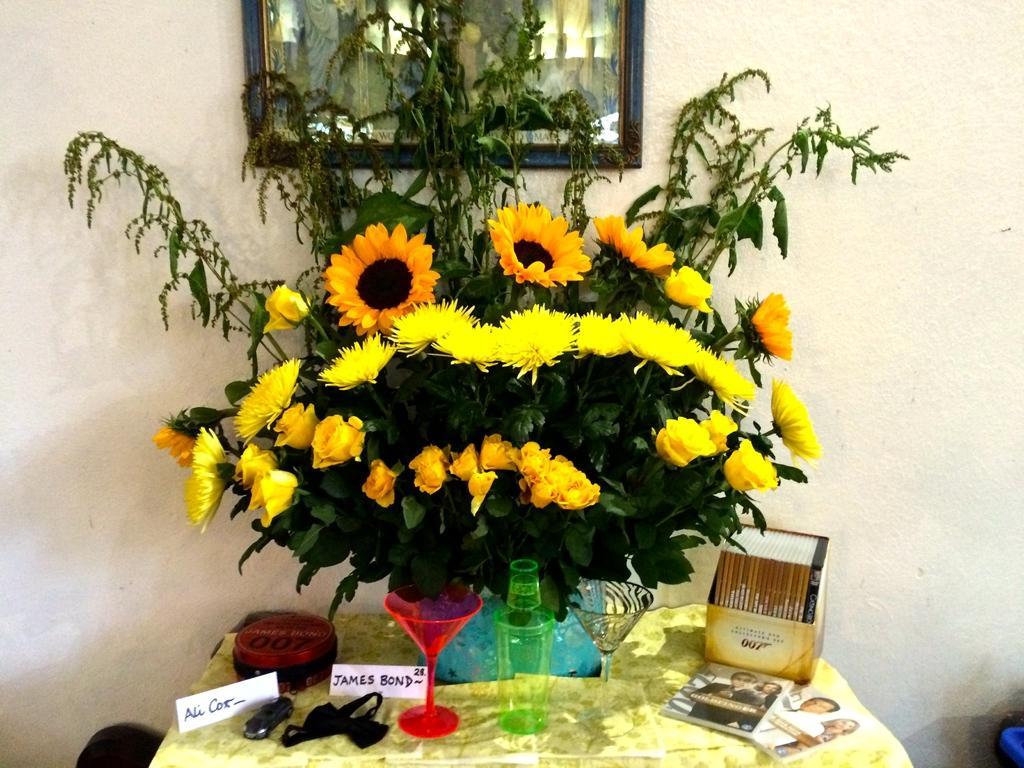Could you give a brief overview of what you see in this image? Here we can see glasses,bottle,name tags,books,flower vase with flowers in it and some other objects on the table. In the background there is a frame on the wall. On the left and right there is an object. 